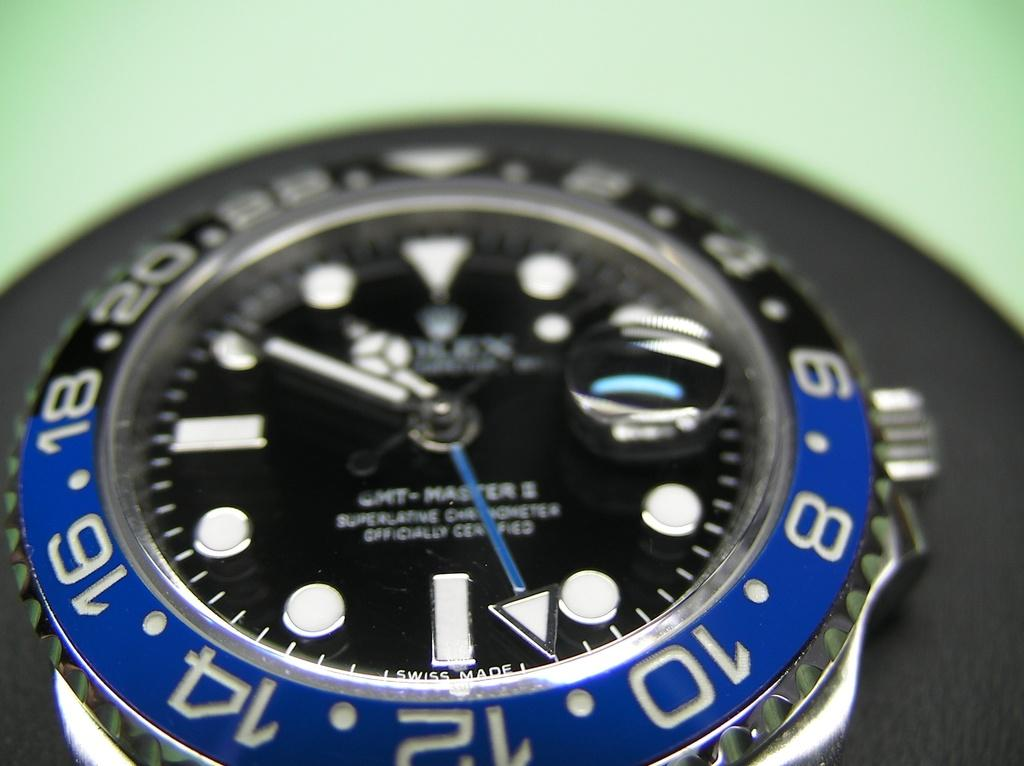Provide a one-sentence caption for the provided image. The numbers on the blue part include 8, 10, 12 and 14. 